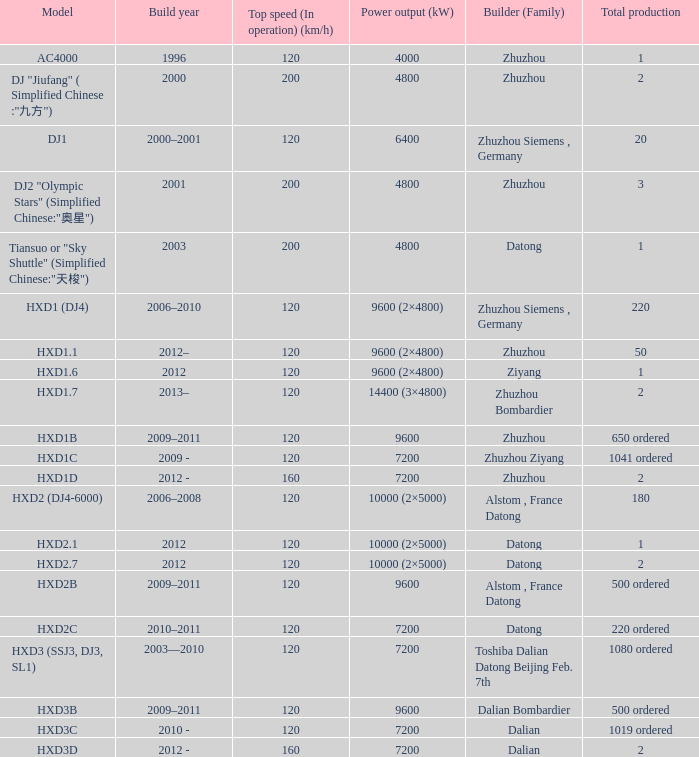What is the power output (kw) of model hxd2b? 9600.0. Write the full table. {'header': ['Model', 'Build year', 'Top speed (In operation) (km/h)', 'Power output (kW)', 'Builder (Family)', 'Total production'], 'rows': [['AC4000', '1996', '120', '4000', 'Zhuzhou', '1'], ['DJ "Jiufang" ( Simplified Chinese :"九方")', '2000', '200', '4800', 'Zhuzhou', '2'], ['DJ1', '2000–2001', '120', '6400', 'Zhuzhou Siemens , Germany', '20'], ['DJ2 "Olympic Stars" (Simplified Chinese:"奥星")', '2001', '200', '4800', 'Zhuzhou', '3'], ['Tiansuo or "Sky Shuttle" (Simplified Chinese:"天梭")', '2003', '200', '4800', 'Datong', '1'], ['HXD1 (DJ4)', '2006–2010', '120', '9600 (2×4800)', 'Zhuzhou Siemens , Germany', '220'], ['HXD1.1', '2012–', '120', '9600 (2×4800)', 'Zhuzhou', '50'], ['HXD1.6', '2012', '120', '9600 (2×4800)', 'Ziyang', '1'], ['HXD1.7', '2013–', '120', '14400 (3×4800)', 'Zhuzhou Bombardier', '2'], ['HXD1B', '2009–2011', '120', '9600', 'Zhuzhou', '650 ordered'], ['HXD1C', '2009 -', '120', '7200', 'Zhuzhou Ziyang', '1041 ordered'], ['HXD1D', '2012 -', '160', '7200', 'Zhuzhou', '2'], ['HXD2 (DJ4-6000)', '2006–2008', '120', '10000 (2×5000)', 'Alstom , France Datong', '180'], ['HXD2.1', '2012', '120', '10000 (2×5000)', 'Datong', '1'], ['HXD2.7', '2012', '120', '10000 (2×5000)', 'Datong', '2'], ['HXD2B', '2009–2011', '120', '9600', 'Alstom , France Datong', '500 ordered'], ['HXD2C', '2010–2011', '120', '7200', 'Datong', '220 ordered'], ['HXD3 (SSJ3, DJ3, SL1)', '2003—2010', '120', '7200', 'Toshiba Dalian Datong Beijing Feb. 7th', '1080 ordered'], ['HXD3B', '2009–2011', '120', '9600', 'Dalian Bombardier', '500 ordered'], ['HXD3C', '2010 -', '120', '7200', 'Dalian', '1019 ordered'], ['HXD3D', '2012 -', '160', '7200', 'Dalian', '2']]} 